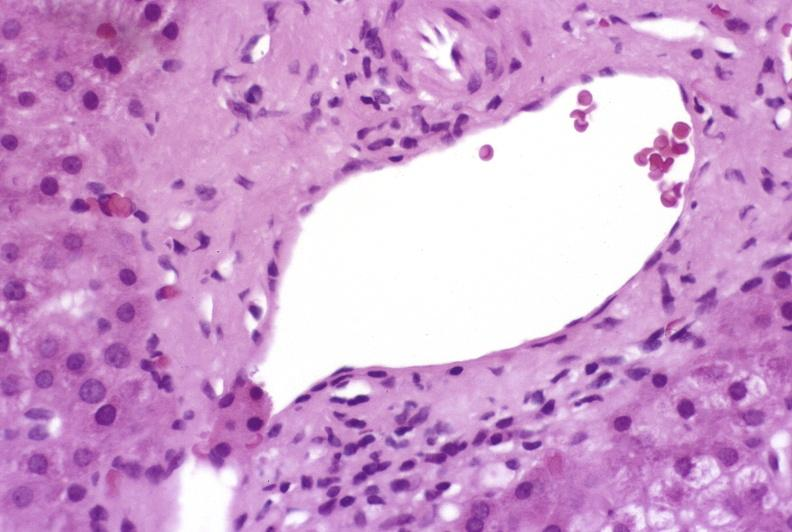s liver present?
Answer the question using a single word or phrase. Yes 